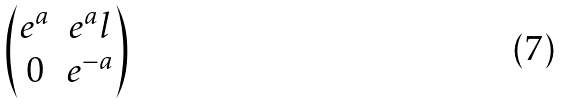<formula> <loc_0><loc_0><loc_500><loc_500>\begin{pmatrix} e ^ { a } & e ^ { a } l \\ 0 & e ^ { - a } \end{pmatrix}</formula> 